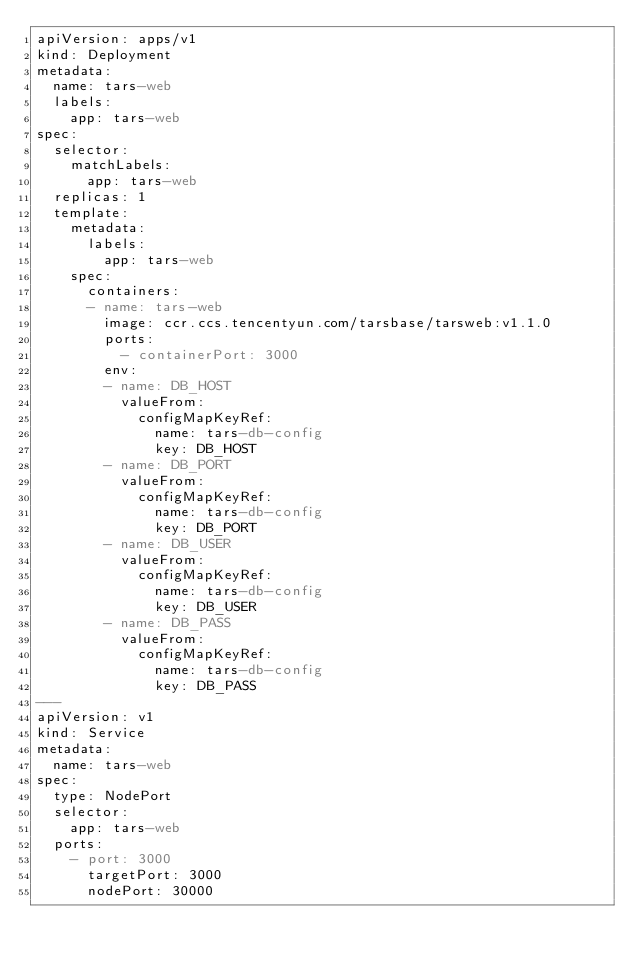Convert code to text. <code><loc_0><loc_0><loc_500><loc_500><_YAML_>apiVersion: apps/v1
kind: Deployment
metadata:
  name: tars-web
  labels:
    app: tars-web
spec:
  selector:
    matchLabels:
      app: tars-web
  replicas: 1
  template:
    metadata:
      labels:
        app: tars-web
    spec:
      containers:
      - name: tars-web
        image: ccr.ccs.tencentyun.com/tarsbase/tarsweb:v1.1.0
        ports:
          - containerPort: 3000
        env:
        - name: DB_HOST
          valueFrom:
            configMapKeyRef:
              name: tars-db-config
              key: DB_HOST
        - name: DB_PORT
          valueFrom:
            configMapKeyRef:
              name: tars-db-config
              key: DB_PORT
        - name: DB_USER
          valueFrom:
            configMapKeyRef:
              name: tars-db-config
              key: DB_USER
        - name: DB_PASS
          valueFrom:
            configMapKeyRef:
              name: tars-db-config
              key: DB_PASS 
---
apiVersion: v1
kind: Service
metadata:
  name: tars-web
spec:
  type: NodePort
  selector:
    app: tars-web
  ports:
    - port: 3000
      targetPort: 3000
      nodePort: 30000
</code> 